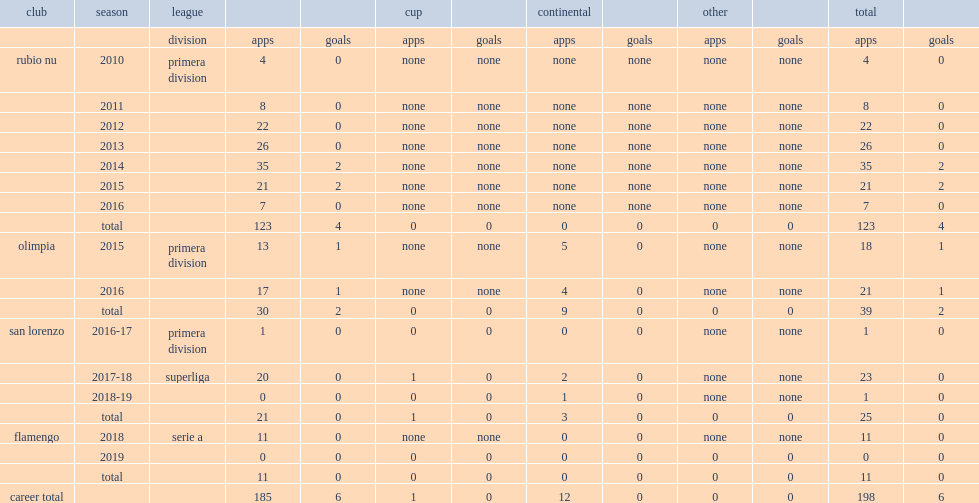Which division did robert piris da motta play for flamengo in 2018? Serie a. 